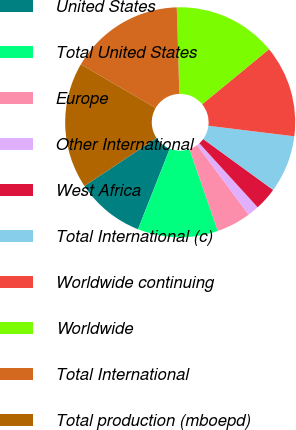Convert chart. <chart><loc_0><loc_0><loc_500><loc_500><pie_chart><fcel>United States<fcel>Total United States<fcel>Europe<fcel>Other International<fcel>West Africa<fcel>Total International (c)<fcel>Worldwide continuing<fcel>Worldwide<fcel>Total International<fcel>Total production (mboepd)<nl><fcel>9.68%<fcel>11.29%<fcel>4.84%<fcel>1.61%<fcel>3.23%<fcel>8.06%<fcel>12.9%<fcel>14.52%<fcel>16.13%<fcel>17.74%<nl></chart> 